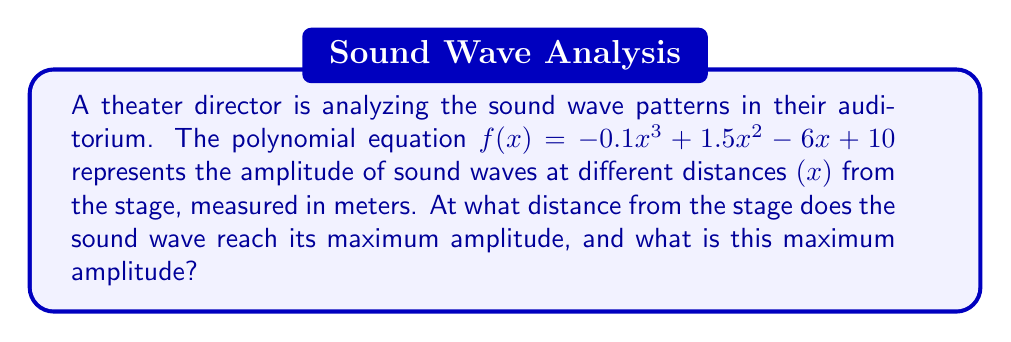Could you help me with this problem? To find the maximum amplitude of the sound wave, we need to follow these steps:

1) First, we need to find the derivative of the function $f(x)$:
   $$f'(x) = -0.3x^2 + 3x - 6$$

2) To find the critical points, set $f'(x) = 0$:
   $$-0.3x^2 + 3x - 6 = 0$$

3) This is a quadratic equation. We can solve it using the quadratic formula:
   $$x = \frac{-b \pm \sqrt{b^2 - 4ac}}{2a}$$
   where $a = -0.3$, $b = 3$, and $c = -6$

4) Substituting these values:
   $$x = \frac{-3 \pm \sqrt{3^2 - 4(-0.3)(-6)}}{2(-0.3)}$$
   $$x = \frac{-3 \pm \sqrt{9 - 7.2}}{-0.6}$$
   $$x = \frac{-3 \pm \sqrt{1.8}}{-0.6}$$
   $$x = \frac{-3 \pm 1.34164}{-0.6}$$

5) This gives us two solutions:
   $$x_1 = \frac{-3 - 1.34164}{-0.6} \approx 7.23607$$
   $$x_2 = \frac{-3 + 1.34164}{-0.6} \approx 2.76393$$

6) To determine which of these gives the maximum (rather than minimum), we can check the second derivative:
   $$f''(x) = -0.6x + 3$$
   
   At $x = 2.76393$, $f''(2.76393) < 0$, indicating a maximum.

7) Therefore, the maximum occurs at approximately 2.76393 meters from the stage.

8) To find the maximum amplitude, we substitute this x-value back into the original function:
   $$f(2.76393) = -0.1(2.76393)^3 + 1.5(2.76393)^2 - 6(2.76393) + 10 \approx 12.3849$$

Thus, the maximum amplitude is approximately 12.3849 units.
Answer: 2.76 m from stage; 12.38 amplitude units 